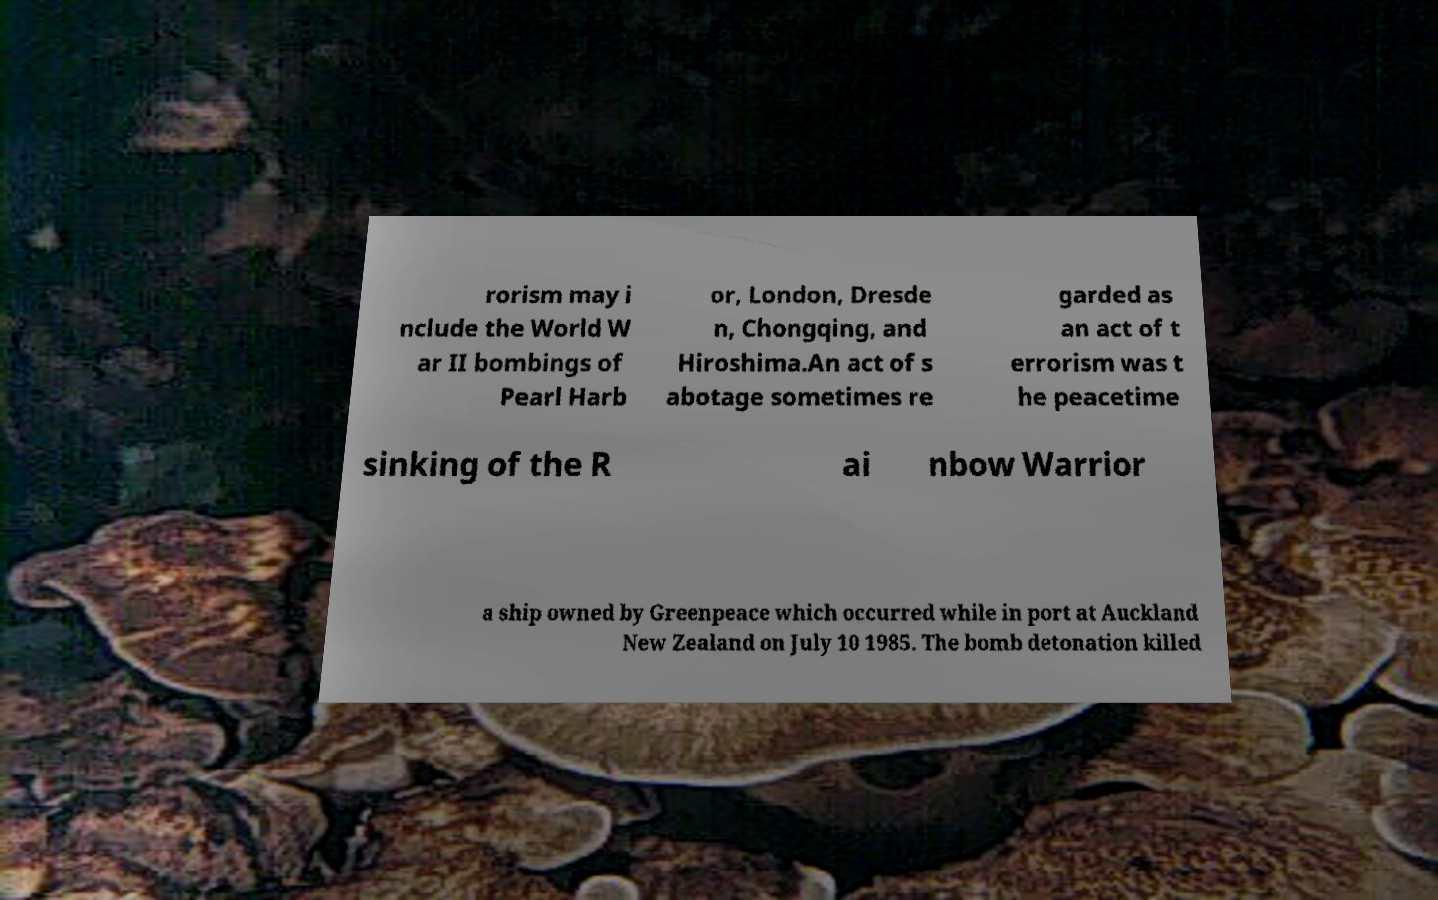Please identify and transcribe the text found in this image. rorism may i nclude the World W ar II bombings of Pearl Harb or, London, Dresde n, Chongqing, and Hiroshima.An act of s abotage sometimes re garded as an act of t errorism was t he peacetime sinking of the R ai nbow Warrior a ship owned by Greenpeace which occurred while in port at Auckland New Zealand on July 10 1985. The bomb detonation killed 